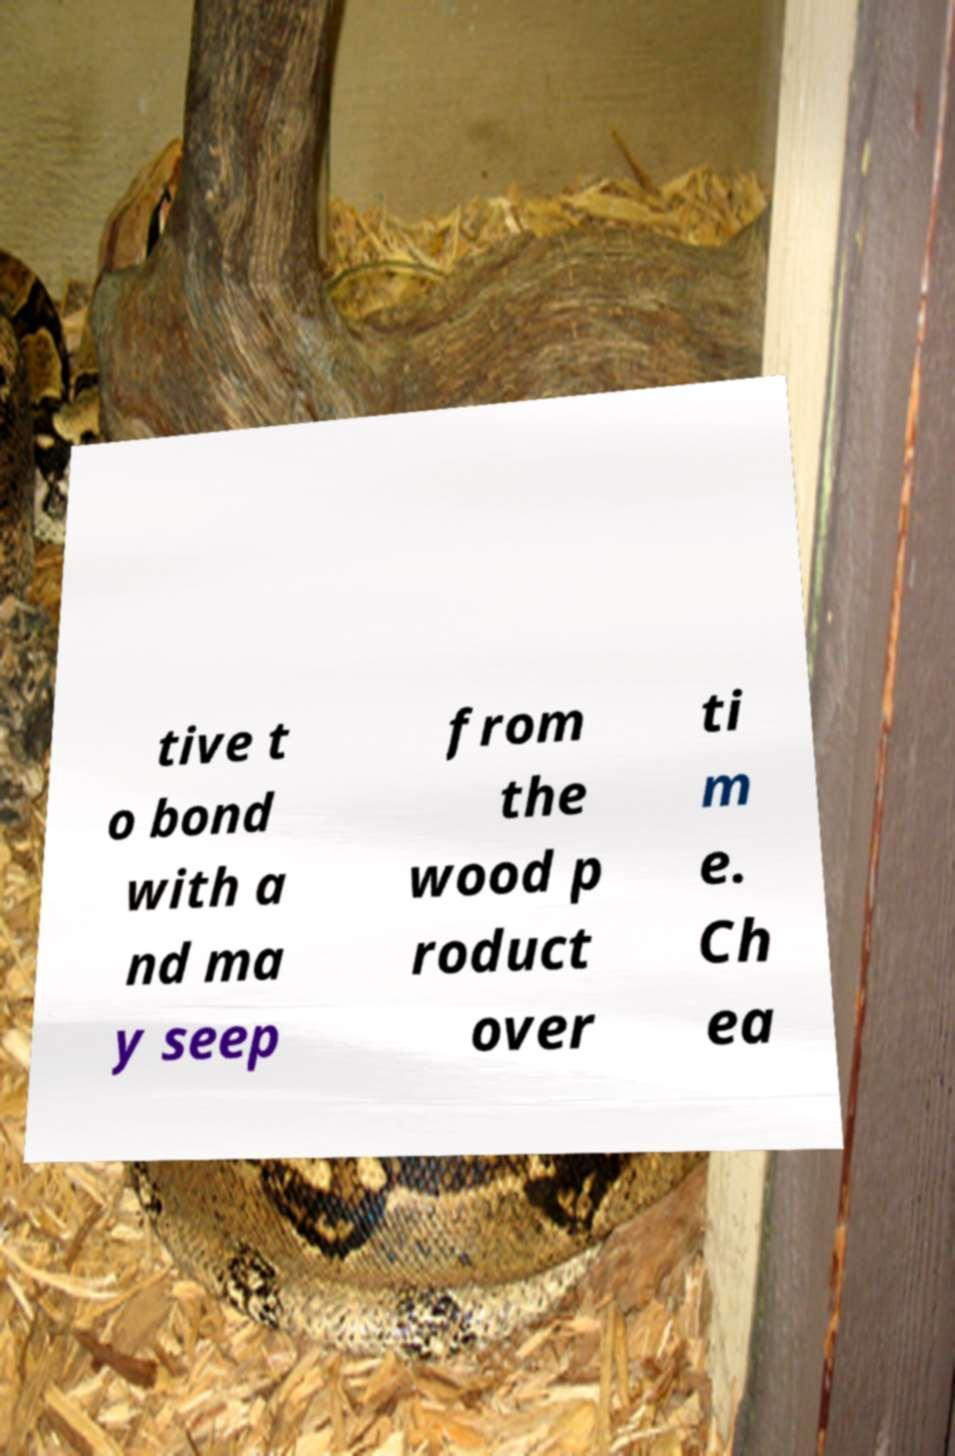What messages or text are displayed in this image? I need them in a readable, typed format. tive t o bond with a nd ma y seep from the wood p roduct over ti m e. Ch ea 